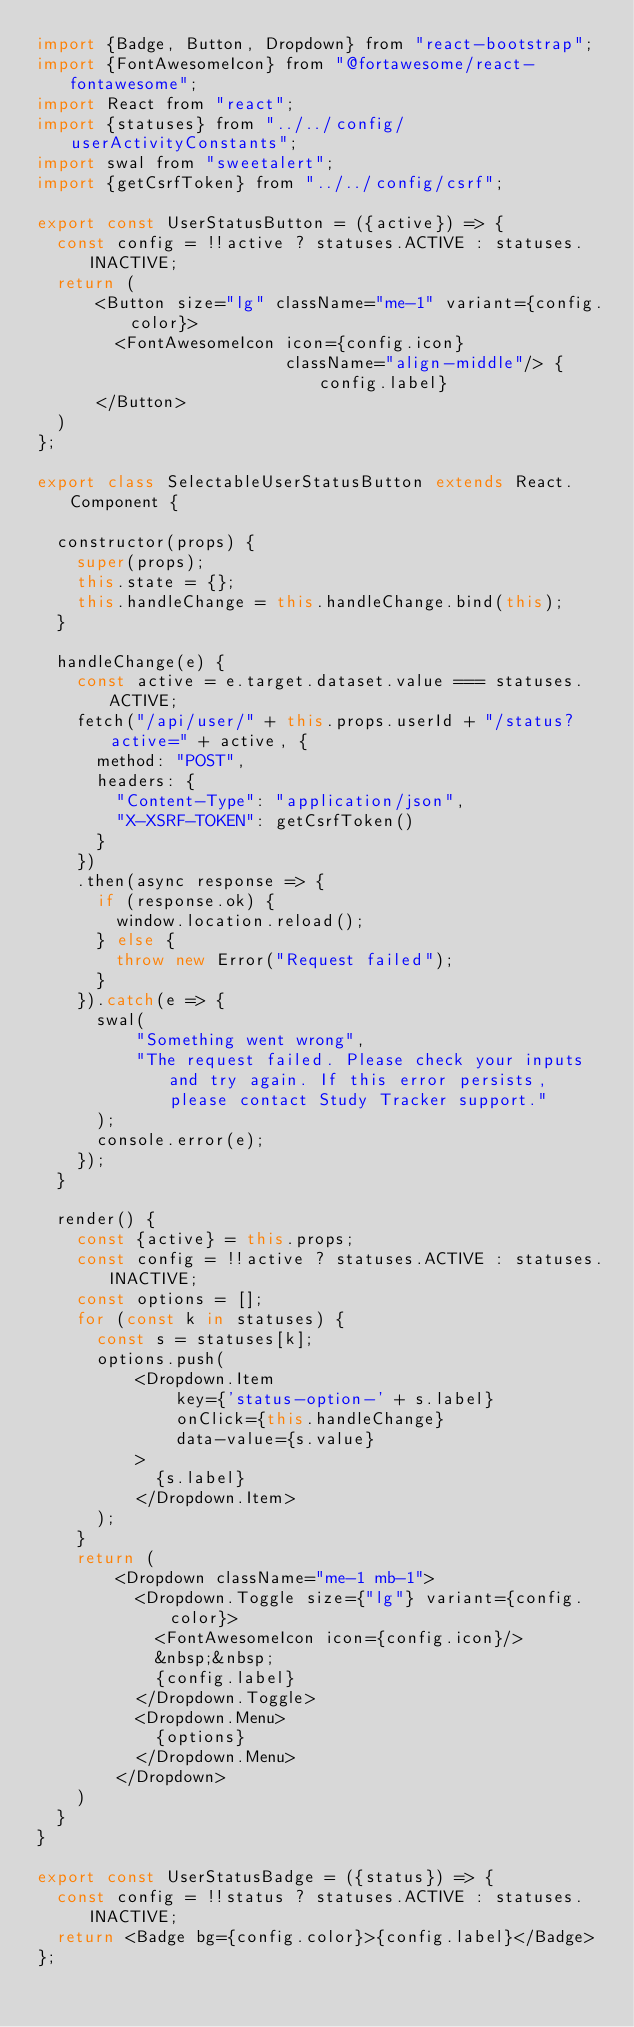<code> <loc_0><loc_0><loc_500><loc_500><_JavaScript_>import {Badge, Button, Dropdown} from "react-bootstrap";
import {FontAwesomeIcon} from "@fortawesome/react-fontawesome";
import React from "react";
import {statuses} from "../../config/userActivityConstants";
import swal from "sweetalert";
import {getCsrfToken} from "../../config/csrf";

export const UserStatusButton = ({active}) => {
  const config = !!active ? statuses.ACTIVE : statuses.INACTIVE;
  return (
      <Button size="lg" className="me-1" variant={config.color}>
        <FontAwesomeIcon icon={config.icon}
                         className="align-middle"/> {config.label}
      </Button>
  )
};

export class SelectableUserStatusButton extends React.Component {

  constructor(props) {
    super(props);
    this.state = {};
    this.handleChange = this.handleChange.bind(this);
  }

  handleChange(e) {
    const active = e.target.dataset.value === statuses.ACTIVE;
    fetch("/api/user/" + this.props.userId + "/status?active=" + active, {
      method: "POST",
      headers: {
        "Content-Type": "application/json",
        "X-XSRF-TOKEN": getCsrfToken()
      }
    })
    .then(async response => {
      if (response.ok) {
        window.location.reload();
      } else {
        throw new Error("Request failed");
      }
    }).catch(e => {
      swal(
          "Something went wrong",
          "The request failed. Please check your inputs and try again. If this error persists, please contact Study Tracker support."
      );
      console.error(e);
    });
  }

  render() {
    const {active} = this.props;
    const config = !!active ? statuses.ACTIVE : statuses.INACTIVE;
    const options = [];
    for (const k in statuses) {
      const s = statuses[k];
      options.push(
          <Dropdown.Item
              key={'status-option-' + s.label}
              onClick={this.handleChange}
              data-value={s.value}
          >
            {s.label}
          </Dropdown.Item>
      );
    }
    return (
        <Dropdown className="me-1 mb-1">
          <Dropdown.Toggle size={"lg"} variant={config.color}>
            <FontAwesomeIcon icon={config.icon}/>
            &nbsp;&nbsp;
            {config.label}
          </Dropdown.Toggle>
          <Dropdown.Menu>
            {options}
          </Dropdown.Menu>
        </Dropdown>
    )
  }
}

export const UserStatusBadge = ({status}) => {
  const config = !!status ? statuses.ACTIVE : statuses.INACTIVE;
  return <Badge bg={config.color}>{config.label}</Badge>
};</code> 